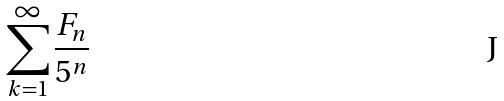<formula> <loc_0><loc_0><loc_500><loc_500>\sum _ { k = 1 } ^ { \infty } \frac { F _ { n } } { 5 ^ { n } }</formula> 